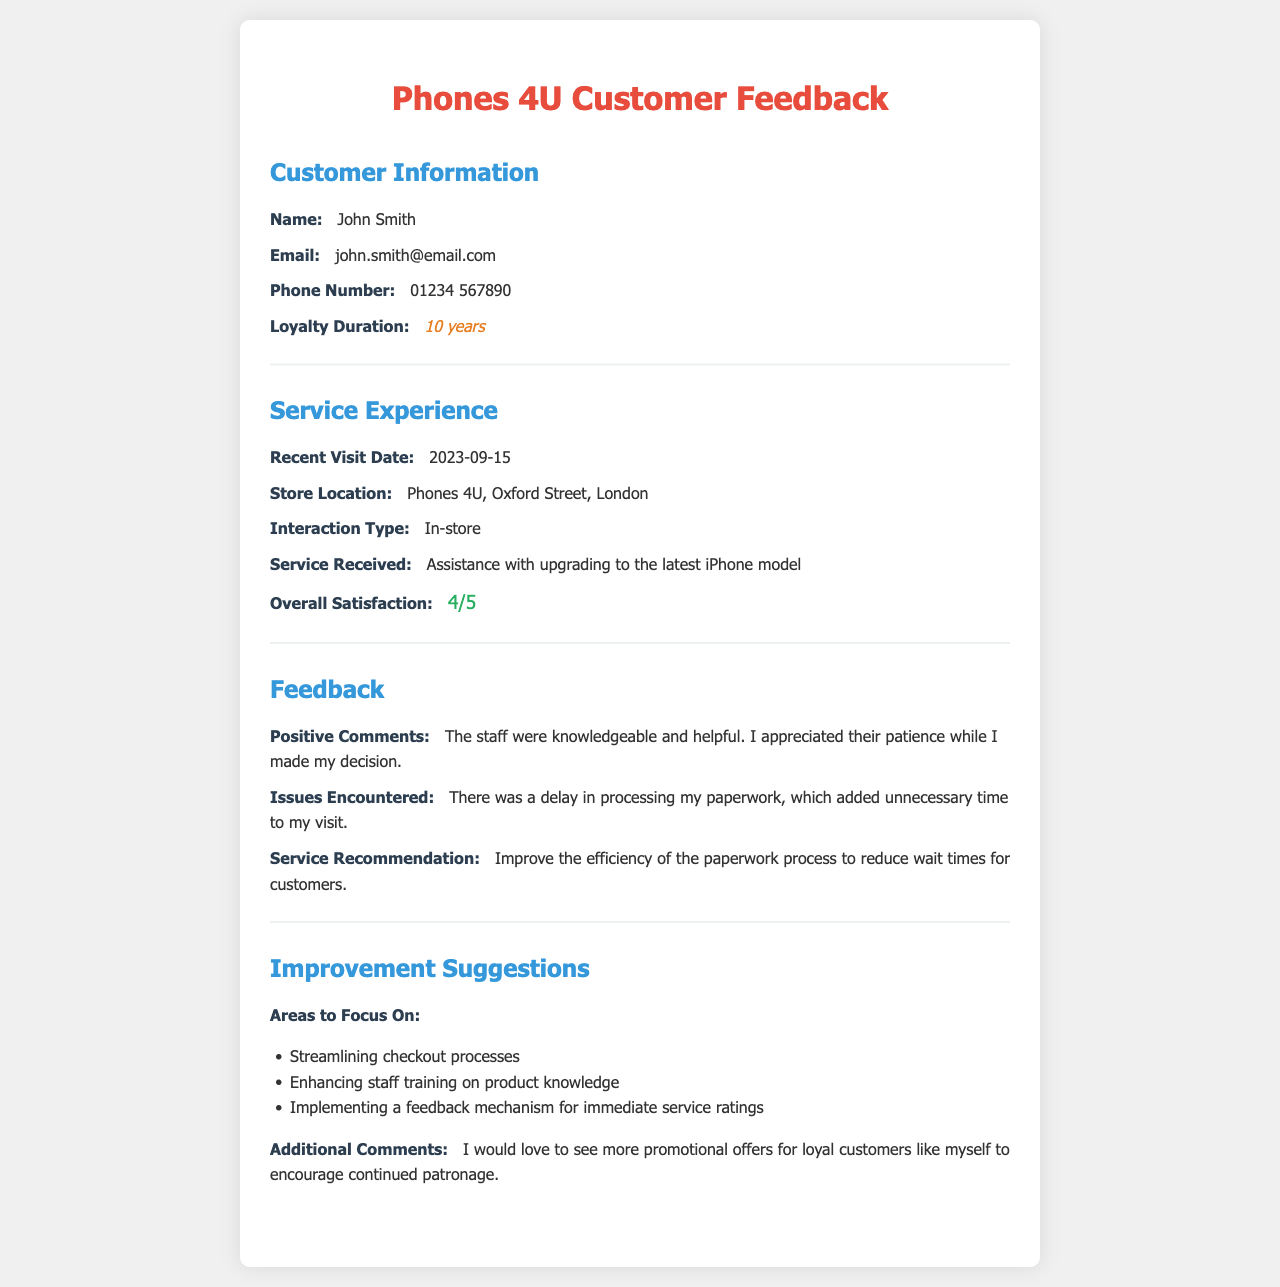what is the customer's name? The customer's name is provided in the Customer Information section of the document.
Answer: John Smith what is the recent visit date? The recent visit date appears in the Service Experience section of the document.
Answer: 2023-09-15 what was the store location? The store location is mentioned in the Service Experience section of the document.
Answer: Phones 4U, Oxford Street, London how satisfied was the customer with the service provided? The overall satisfaction rating is found in the Service Experience section of the document.
Answer: 4/5 what issue did the customer encounter? The issue the customer encountered is listed in the Feedback section of the document.
Answer: Delay in processing paperwork what are the suggested areas for improvement? The suggested areas for improvement are listed in the Improvement Suggestions section of the document.
Answer: Streamlining checkout processes, Enhancing staff training on product knowledge, Implementing a feedback mechanism for immediate service ratings what did the customer say about staff interaction? The comment regarding staff interaction can be found in the Feedback section.
Answer: The staff were knowledgeable and helpful what promotional suggestion did the customer make? The customer's suggestion regarding promotions is noted in the Improvement Suggestions section.
Answer: More promotional offers for loyal customers 